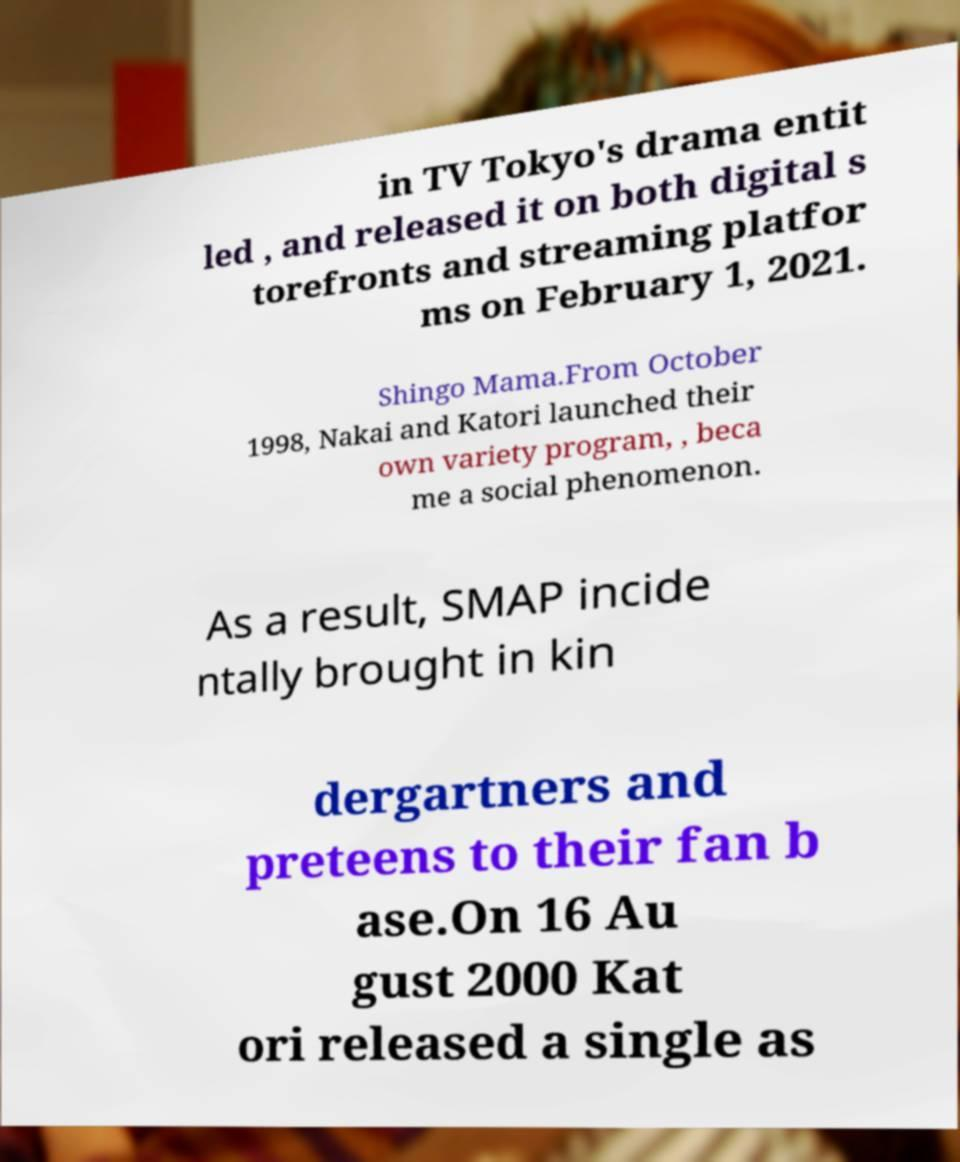Could you assist in decoding the text presented in this image and type it out clearly? in TV Tokyo's drama entit led , and released it on both digital s torefronts and streaming platfor ms on February 1, 2021. Shingo Mama.From October 1998, Nakai and Katori launched their own variety program, , beca me a social phenomenon. As a result, SMAP incide ntally brought in kin dergartners and preteens to their fan b ase.On 16 Au gust 2000 Kat ori released a single as 